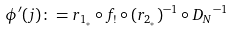Convert formula to latex. <formula><loc_0><loc_0><loc_500><loc_500>\phi ^ { \prime } ( j ) \colon = r _ { 1 _ { * } } \circ f _ { ! } \circ ( r _ { 2 _ { * } } ) ^ { - 1 } \circ { D _ { N } } ^ { - 1 }</formula> 